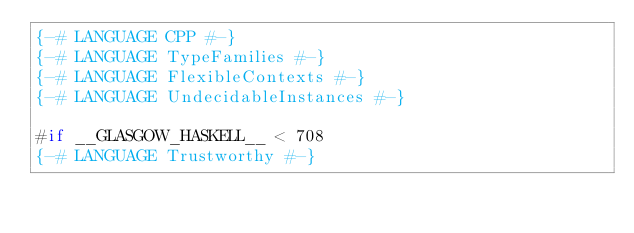Convert code to text. <code><loc_0><loc_0><loc_500><loc_500><_Haskell_>{-# LANGUAGE CPP #-}
{-# LANGUAGE TypeFamilies #-}
{-# LANGUAGE FlexibleContexts #-}
{-# LANGUAGE UndecidableInstances #-}

#if __GLASGOW_HASKELL__ < 708
{-# LANGUAGE Trustworthy #-}</code> 